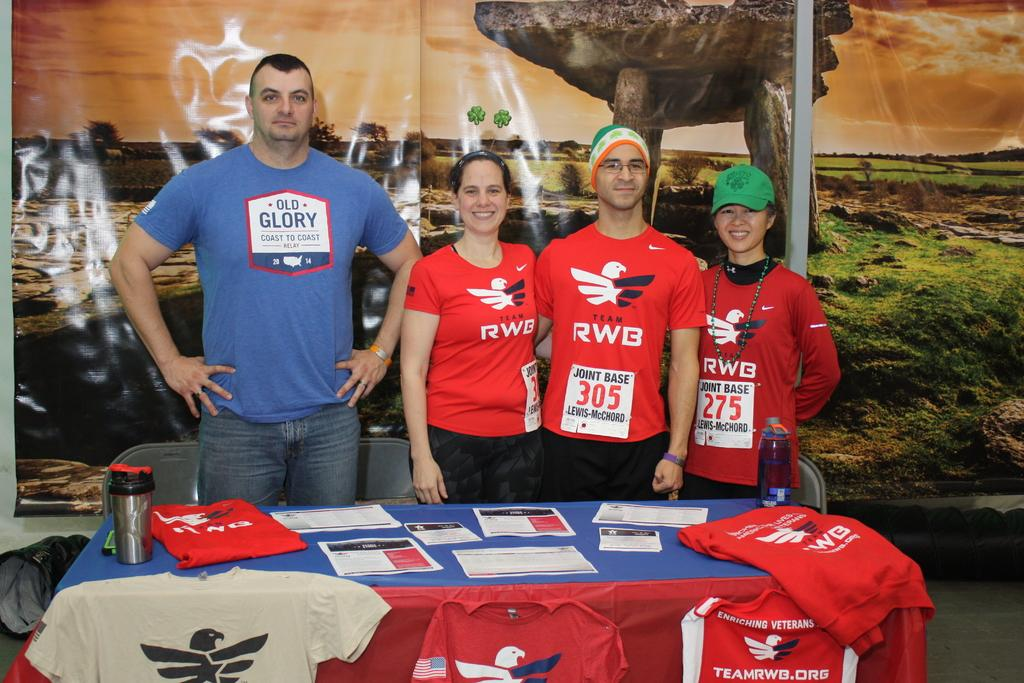<image>
Present a compact description of the photo's key features. people standing behind a display table in shirts reading RWB 